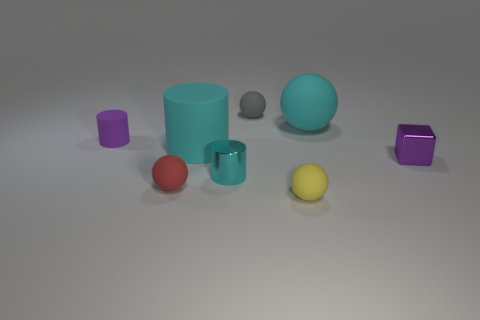What is the color of the small cylinder that is in front of the purple thing to the right of the small red rubber sphere?
Your answer should be very brief. Cyan. How many things are tiny shiny things on the right side of the small cyan cylinder or matte spheres that are behind the tiny yellow object?
Offer a terse response. 4. What color is the big matte sphere?
Your answer should be compact. Cyan. What number of large red things have the same material as the gray object?
Your answer should be very brief. 0. Are there more small matte spheres than rubber spheres?
Offer a terse response. No. There is a small purple thing behind the small purple metal block; what number of shiny cylinders are right of it?
Your response must be concise. 1. How many objects are matte cylinders to the right of the tiny purple rubber cylinder or small purple rubber things?
Offer a very short reply. 2. Are there any cyan objects of the same shape as the gray matte thing?
Keep it short and to the point. Yes. What is the shape of the tiny metallic thing that is left of the purple metallic block that is behind the red matte ball?
Offer a very short reply. Cylinder. What number of cylinders are small red rubber objects or large objects?
Give a very brief answer. 1. 